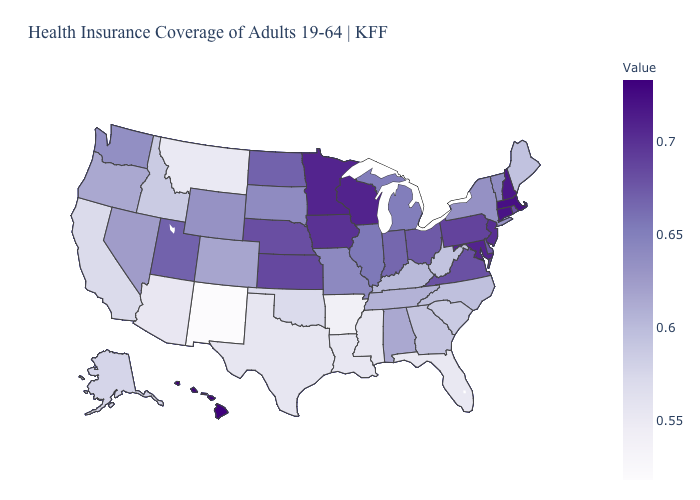Among the states that border Kentucky , does Virginia have the highest value?
Keep it brief. Yes. Which states hav the highest value in the Northeast?
Answer briefly. Massachusetts. 